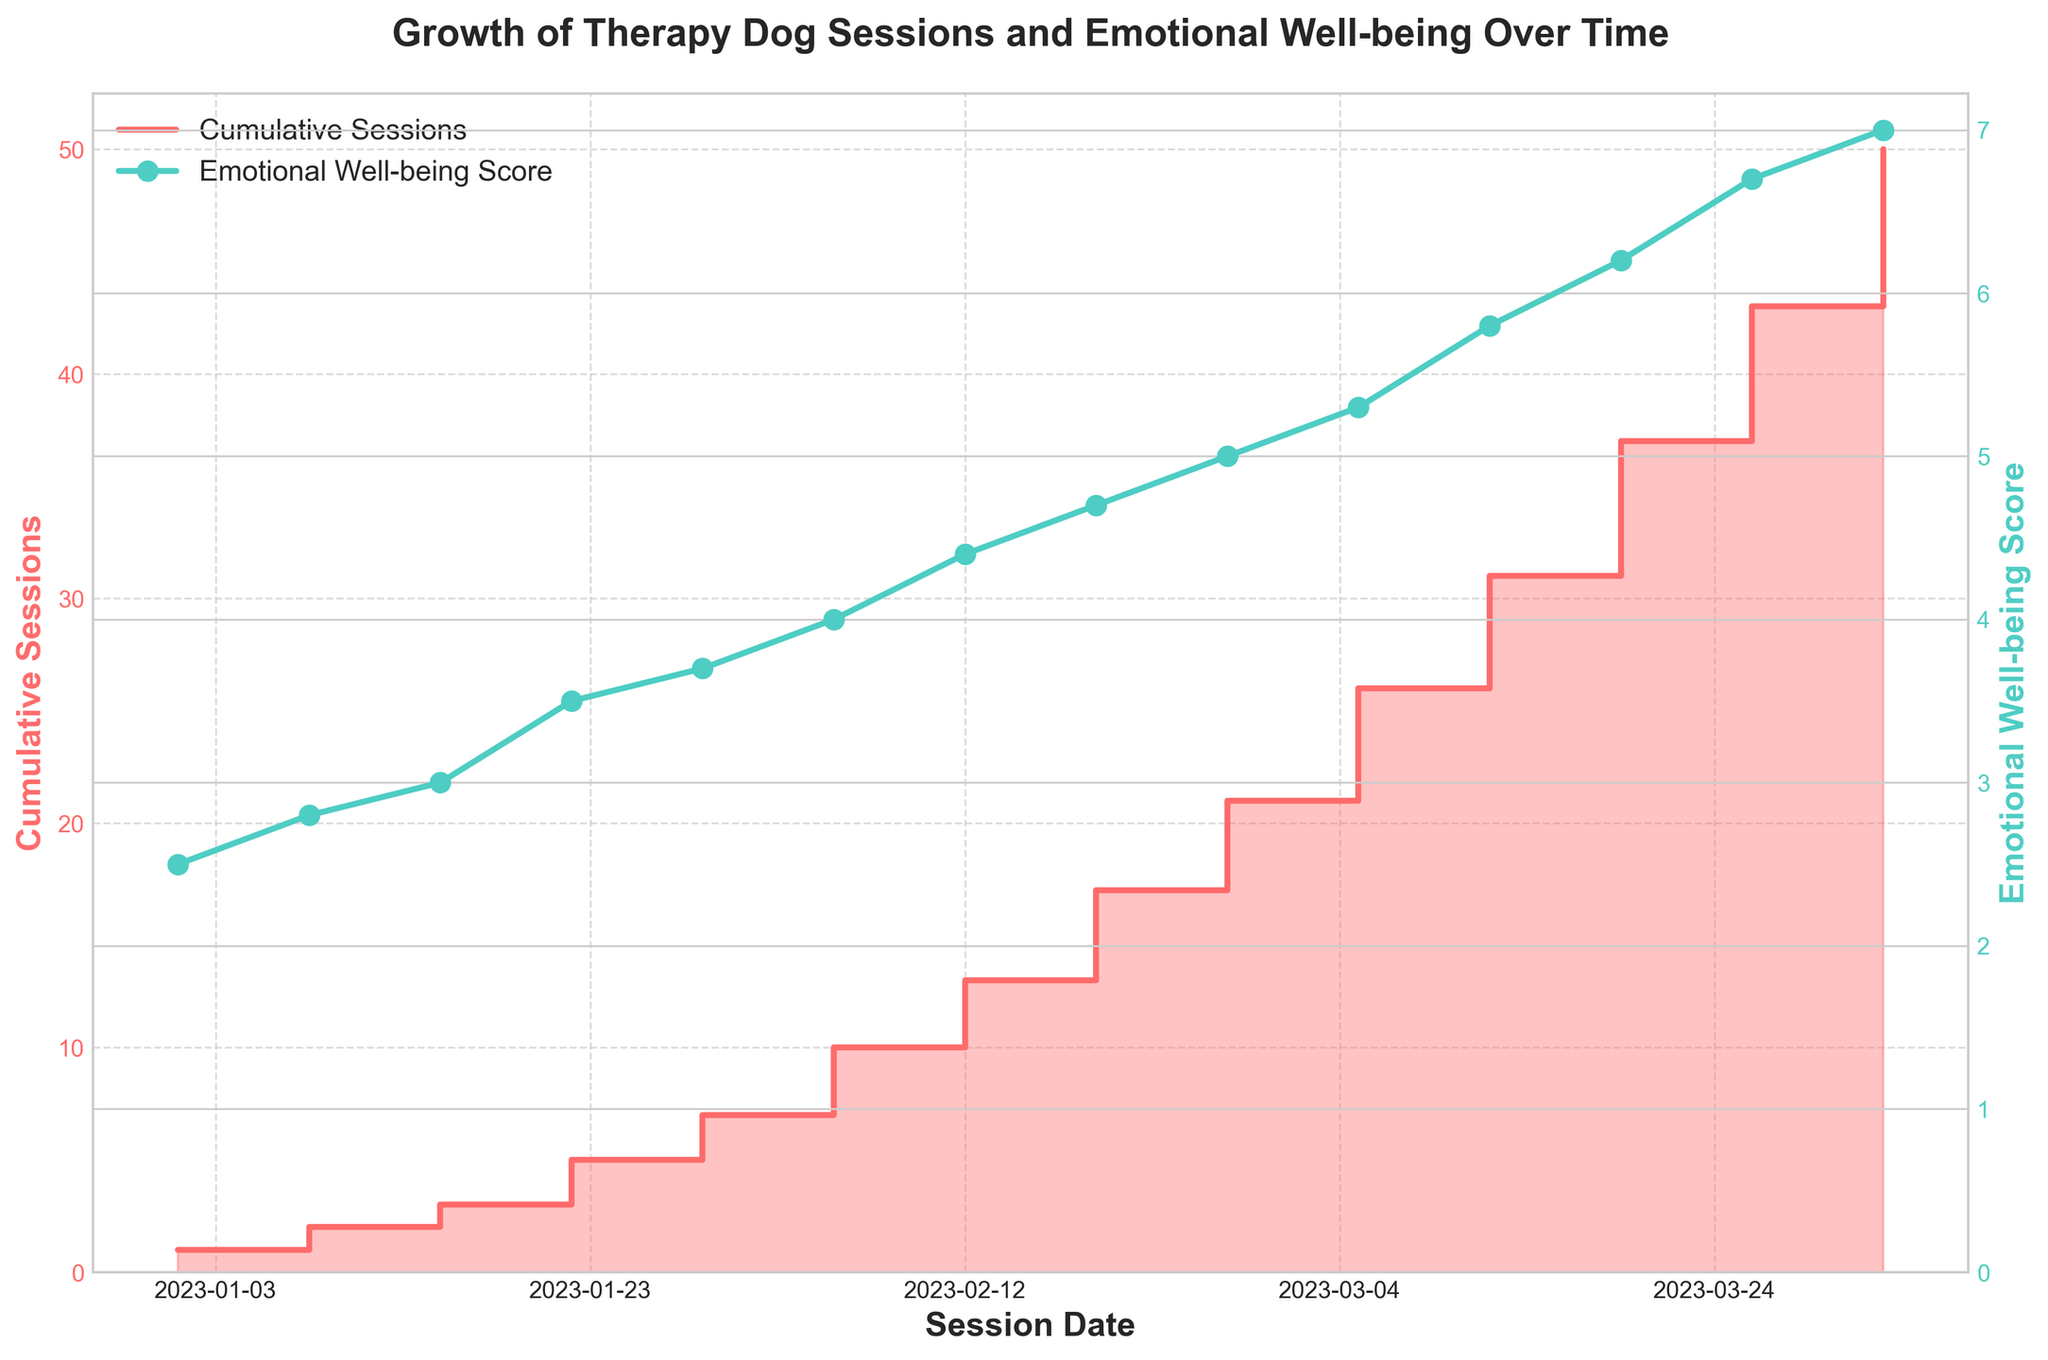What's the title of the figure? The title is usually displayed at the top of the figure, and in this case, it reads "Growth of Therapy Dog Sessions and Emotional Well-being Over Time".
Answer: Growth of Therapy Dog Sessions and Emotional Well-being Over Time Which color represents the 'Cumulative Sessions' in the chart? The 'Cumulative Sessions' are represented in the step area chart with a fill, and the color used is a shade of red.
Answer: Red How many sessions were there by February 26, 2023? Look at the step line for 'Cumulative Sessions' and find the date. The value at this step represents the cumulative number of sessions by February 26, 2023.
Answer: 21 What is the 'Emotional Well-being Score' on March 12, 2023? Find March 12, 2023, and follow the plot for 'Emotional Well-being Score' marked with green dots. The value at this point should be evident.
Answer: 5.8 Between which dates did the steepest increase in 'Cumulative Sessions' occur? Identify the segment of the step area chart where the vertical increase between two consecutive steps is the highest.
Answer: March 19, 2023 to April 2, 2023 What was the increase in the 'Emotional Well-being Score' from January 1, 2023 to February 5, 2023? Find the 'Emotional Well-being Score' on January 1, 2023 and February 5, 2023, then subtract the earlier score from the latter.
Answer: 4.0 - 2.5 = 1.5 On which date did the 'Cumulative Sessions' reach 10? Look for the date where the step line first touches the value 10. Following the x-axis, find the corresponding date.
Answer: February 5, 2023 How many more sessions were added between February 12 and February 26, 2023? Find the 'Cumulative Sessions' on both dates, then subtract the former from the latter to get the number of sessions added in this time period.
Answer: 21 - 13 = 8 By how much did the 'Emotional Well-being Score' increase between February 19 and March 26, 2023? Find the 'Emotional Well-being Score' for both dates and subtract the earlier value from the later one.
Answer: 6.7 - 4.7 = 2.0 